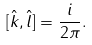<formula> <loc_0><loc_0><loc_500><loc_500>[ \hat { k } , \hat { l } ] = \frac { i } { 2 \pi } .</formula> 